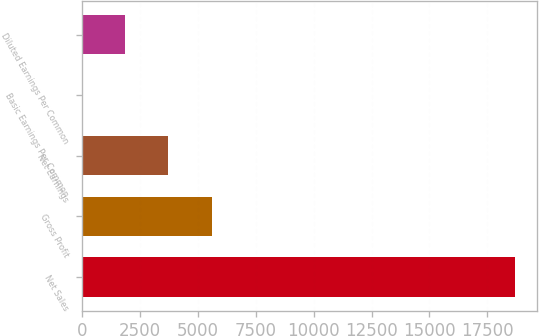Convert chart. <chart><loc_0><loc_0><loc_500><loc_500><bar_chart><fcel>Net Sales<fcel>Gross Profit<fcel>Net Earnings<fcel>Basic Earnings Per Common<fcel>Diluted Earnings Per Common<nl><fcel>18708<fcel>5612.96<fcel>3742.24<fcel>0.8<fcel>1871.52<nl></chart> 